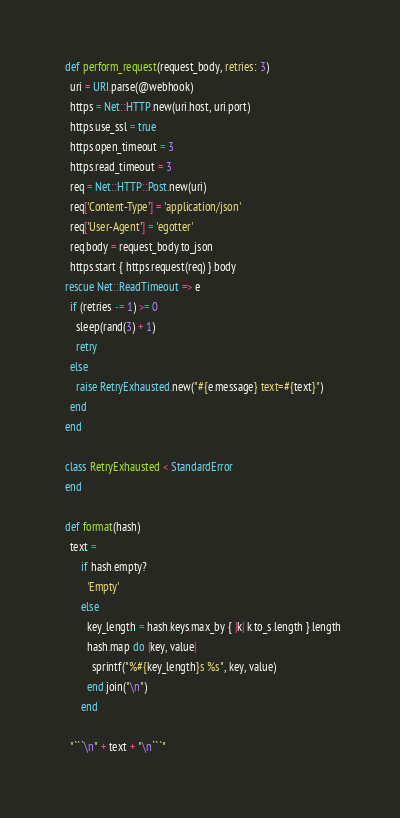<code> <loc_0><loc_0><loc_500><loc_500><_Ruby_>
  def perform_request(request_body, retries: 3)
    uri = URI.parse(@webhook)
    https = Net::HTTP.new(uri.host, uri.port)
    https.use_ssl = true
    https.open_timeout = 3
    https.read_timeout = 3
    req = Net::HTTP::Post.new(uri)
    req['Content-Type'] = 'application/json'
    req['User-Agent'] = 'egotter'
    req.body = request_body.to_json
    https.start { https.request(req) }.body
  rescue Net::ReadTimeout => e
    if (retries -= 1) >= 0
      sleep(rand(3) + 1)
      retry
    else
      raise RetryExhausted.new("#{e.message} text=#{text}")
    end
  end

  class RetryExhausted < StandardError
  end

  def format(hash)
    text =
        if hash.empty?
          'Empty'
        else
          key_length = hash.keys.max_by { |k| k.to_s.length }.length
          hash.map do |key, value|
            sprintf("%#{key_length}s %s", key, value)
          end.join("\n")
        end

    "```\n" + text + "\n```"</code> 